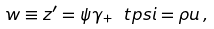Convert formula to latex. <formula><loc_0><loc_0><loc_500><loc_500>w \equiv z ^ { \prime } = \psi \gamma _ { + } \ t p s i = \rho u \, ,</formula> 